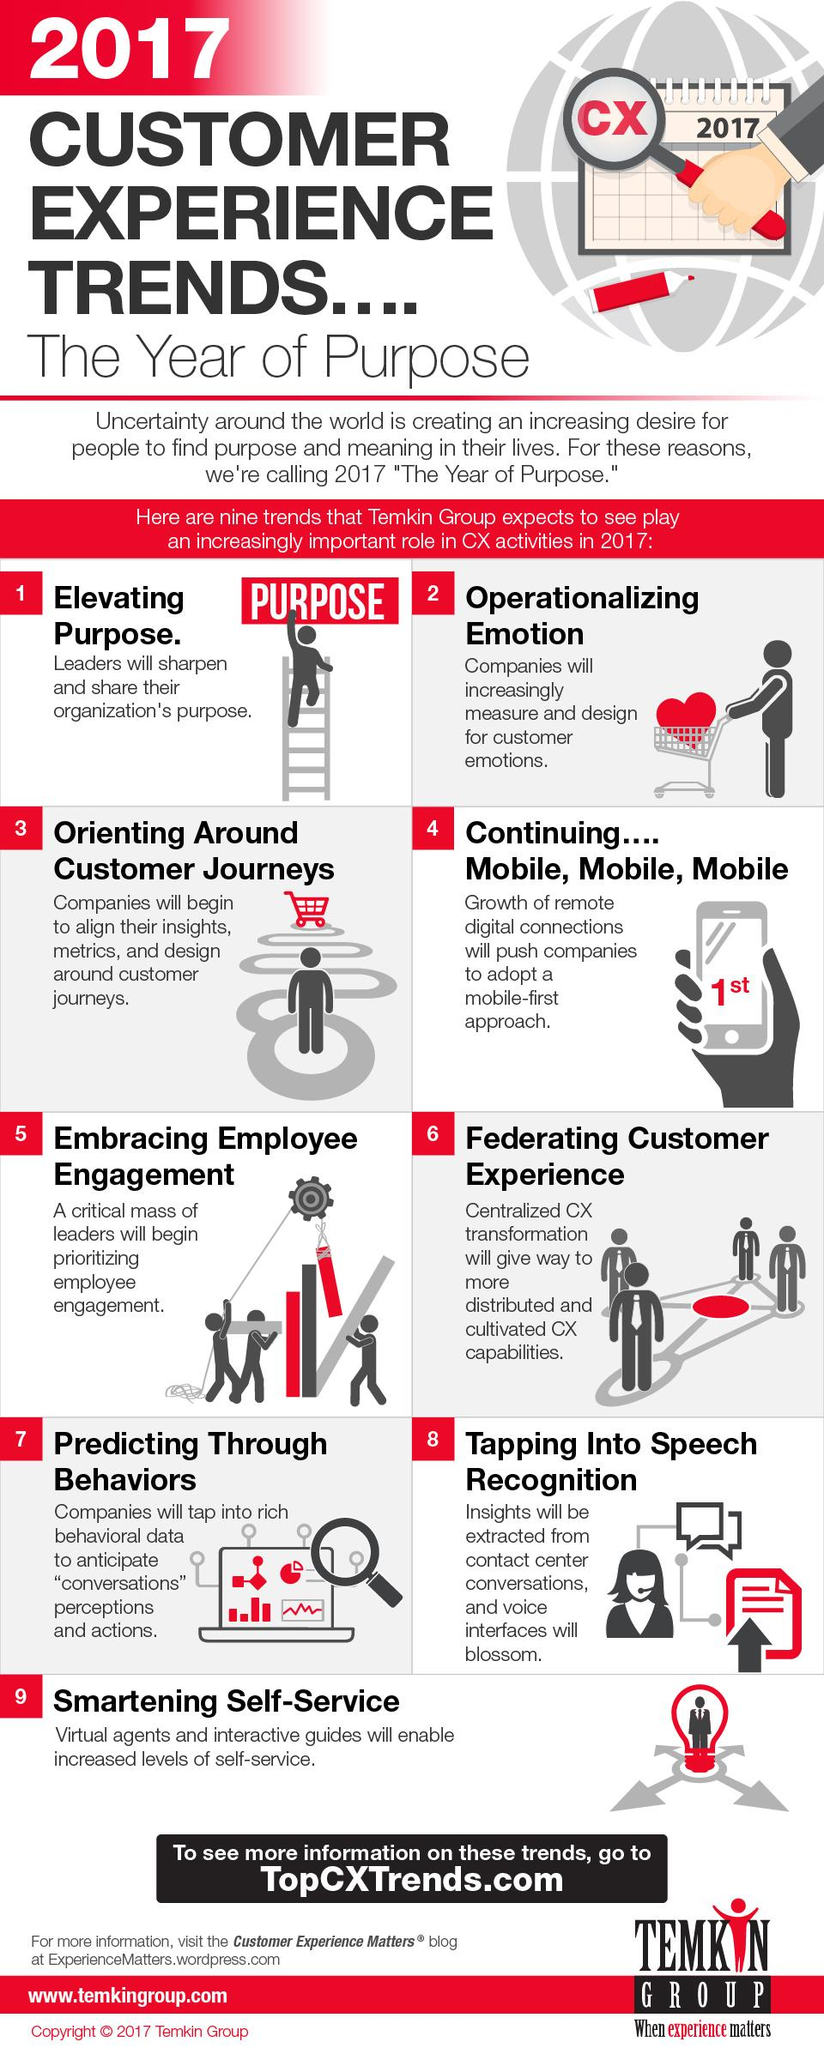Mention a couple of crucial points in this snapshot. Trend 7 taps into customers' behavioral patterns, offering a unique approach that is in line with current market demands. The use of speech recognition technology is increasingly popular among users, as it allows for the collection of behavioral data, voice-related data, and speech recognition information. Speech recognition technology, specifically, is becoming a popular trend in the market. 